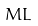Convert formula to latex. <formula><loc_0><loc_0><loc_500><loc_500>M L</formula> 